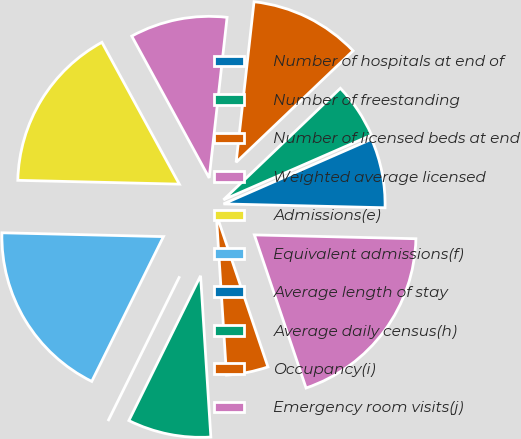<chart> <loc_0><loc_0><loc_500><loc_500><pie_chart><fcel>Number of hospitals at end of<fcel>Number of freestanding<fcel>Number of licensed beds at end<fcel>Weighted average licensed<fcel>Admissions(e)<fcel>Equivalent admissions(f)<fcel>Average length of stay<fcel>Average daily census(h)<fcel>Occupancy(i)<fcel>Emergency room visits(j)<nl><fcel>6.94%<fcel>5.56%<fcel>11.11%<fcel>9.72%<fcel>16.67%<fcel>18.06%<fcel>0.0%<fcel>8.33%<fcel>4.17%<fcel>19.44%<nl></chart> 